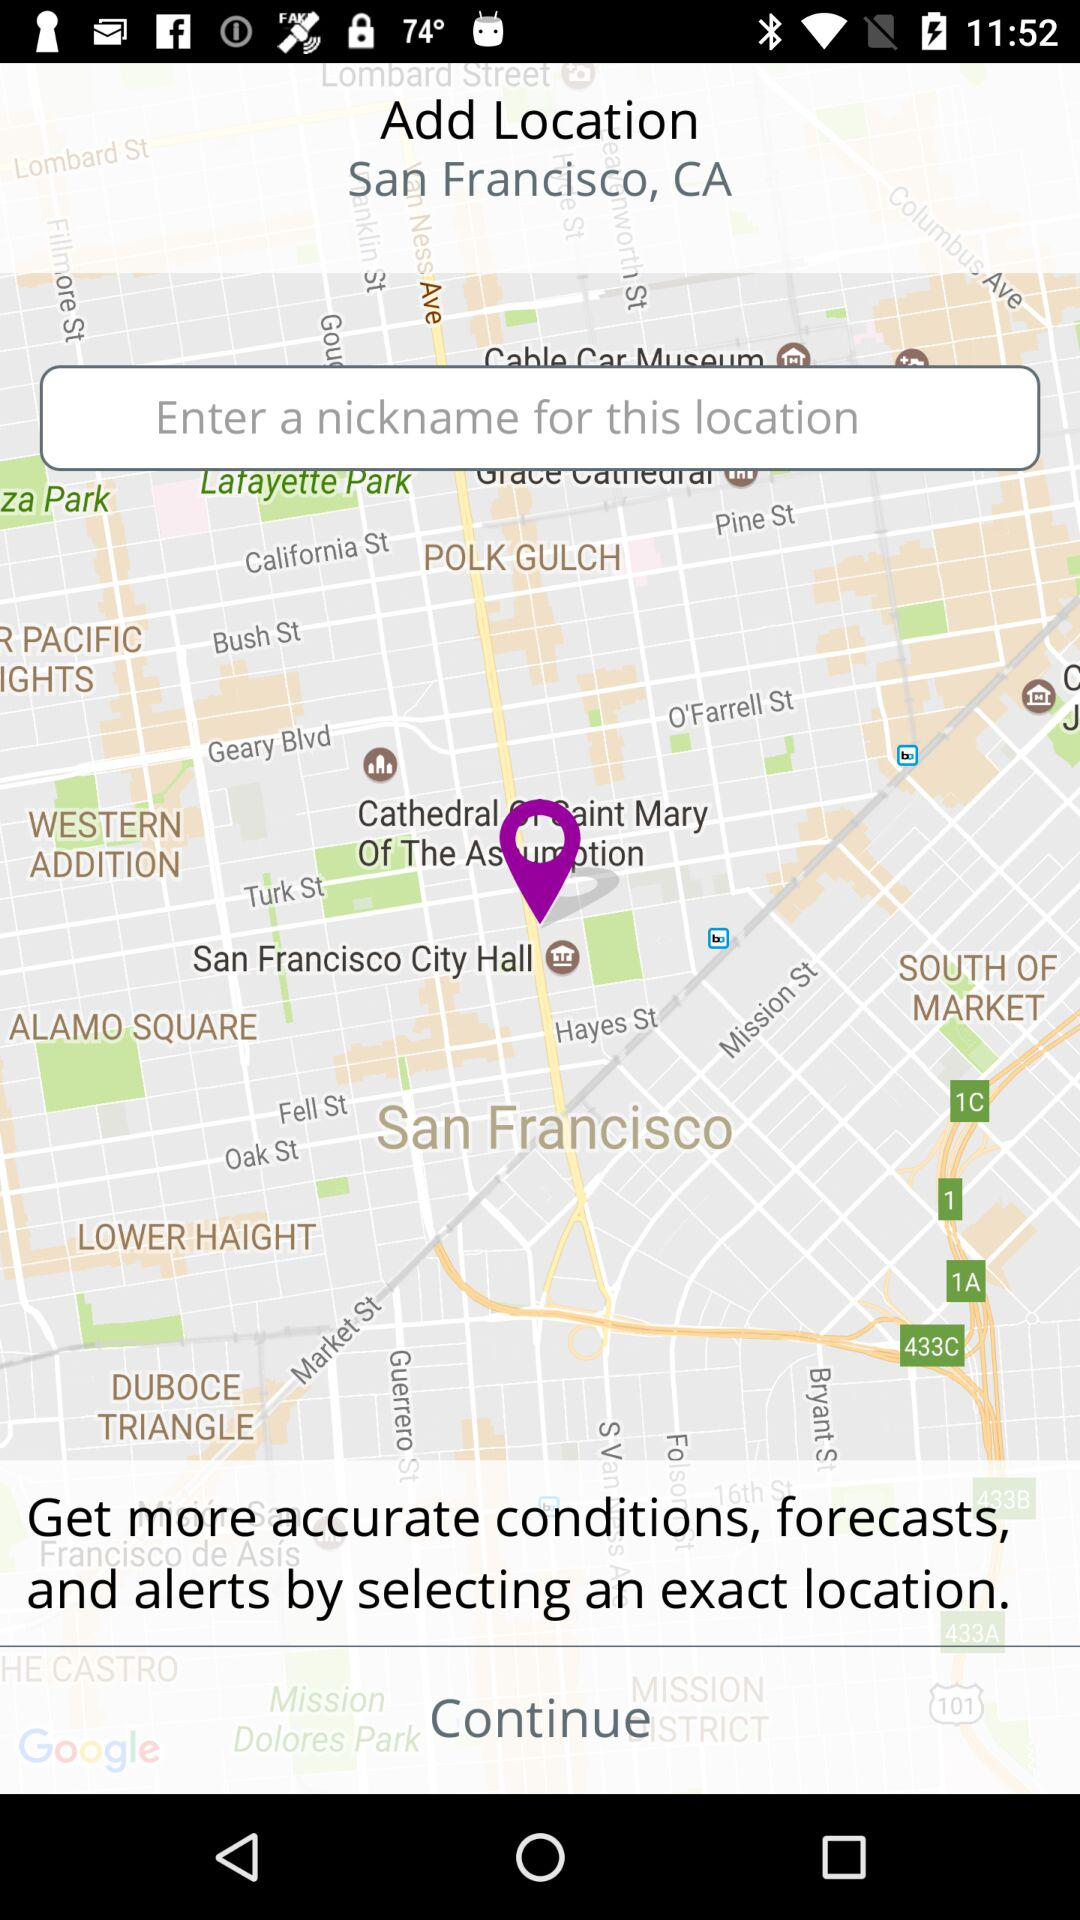What is the mentioned location? The mentioned location is San Francisco, CA. 